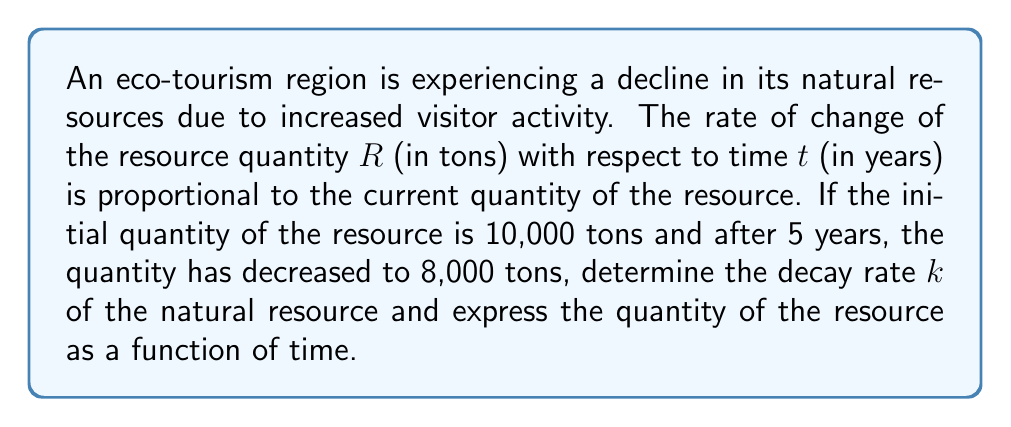What is the answer to this math problem? To solve this problem, we'll use the first-order differential equation for exponential decay:

$$\frac{dR}{dt} = -kR$$

where $k$ is the decay rate constant.

The solution to this differential equation is:

$$R(t) = R_0e^{-kt}$$

where $R_0$ is the initial quantity of the resource.

Given:
- Initial quantity $R_0 = 10,000$ tons
- After 5 years, $R(5) = 8,000$ tons

Let's solve for $k$:

$$8000 = 10000e^{-5k}$$

Dividing both sides by 10000:

$$0.8 = e^{-5k}$$

Taking the natural logarithm of both sides:

$$\ln(0.8) = -5k$$

Solving for $k$:

$$k = -\frac{\ln(0.8)}{5} \approx 0.0446$$

Now that we have $k$, we can express the quantity of the resource as a function of time:

$$R(t) = 10000e^{-0.0446t}$$

This equation represents the quantity of the natural resource (in tons) at any given time $t$ (in years) after the initial measurement.
Answer: The decay rate $k \approx 0.0446$ per year, and the quantity of the resource as a function of time is $R(t) = 10000e^{-0.0446t}$ tons, where $t$ is measured in years. 